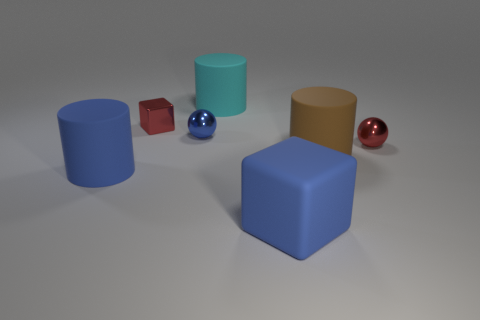Subtract all cylinders. How many objects are left? 4 Add 1 large yellow cylinders. How many objects exist? 8 Subtract all small blue spheres. Subtract all gray objects. How many objects are left? 6 Add 4 big matte blocks. How many big matte blocks are left? 5 Add 3 large rubber cubes. How many large rubber cubes exist? 4 Subtract 1 blue cubes. How many objects are left? 6 